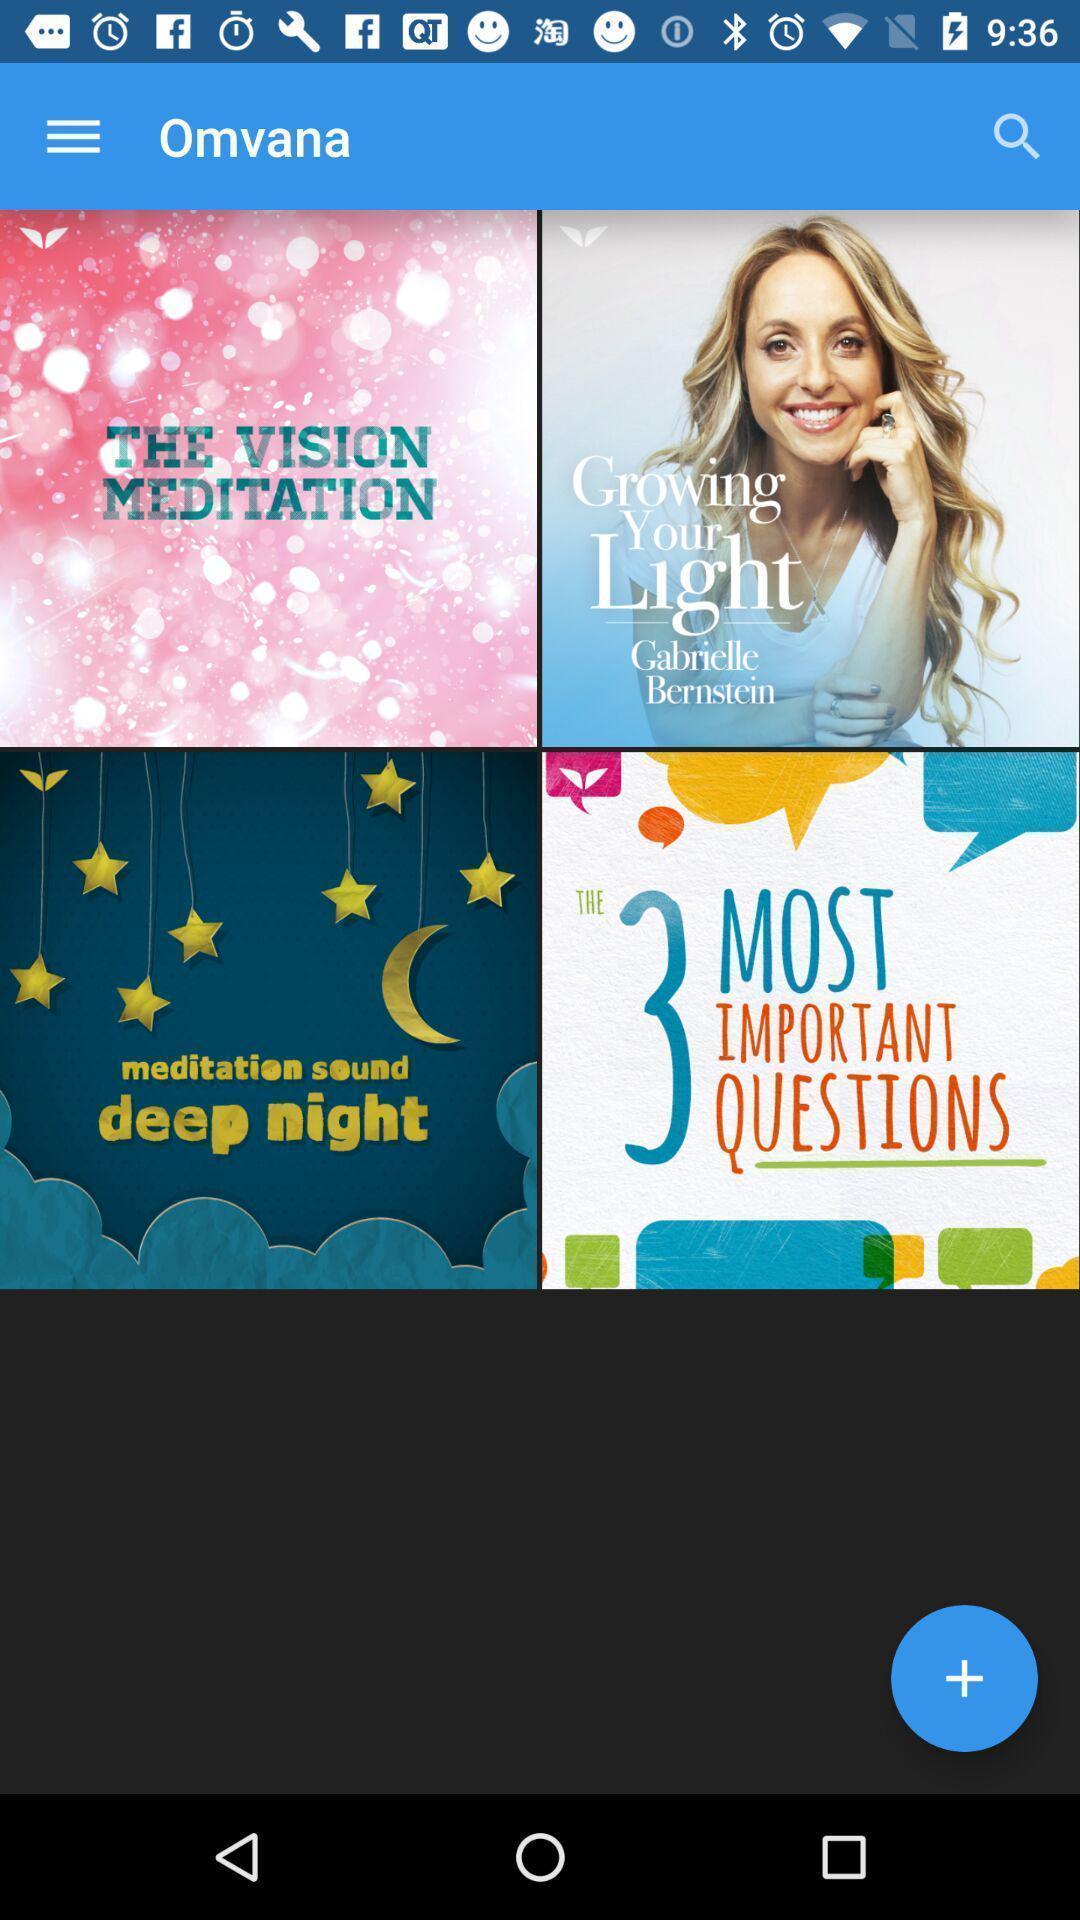Provide a detailed account of this screenshot. Page showing various categories on app. 